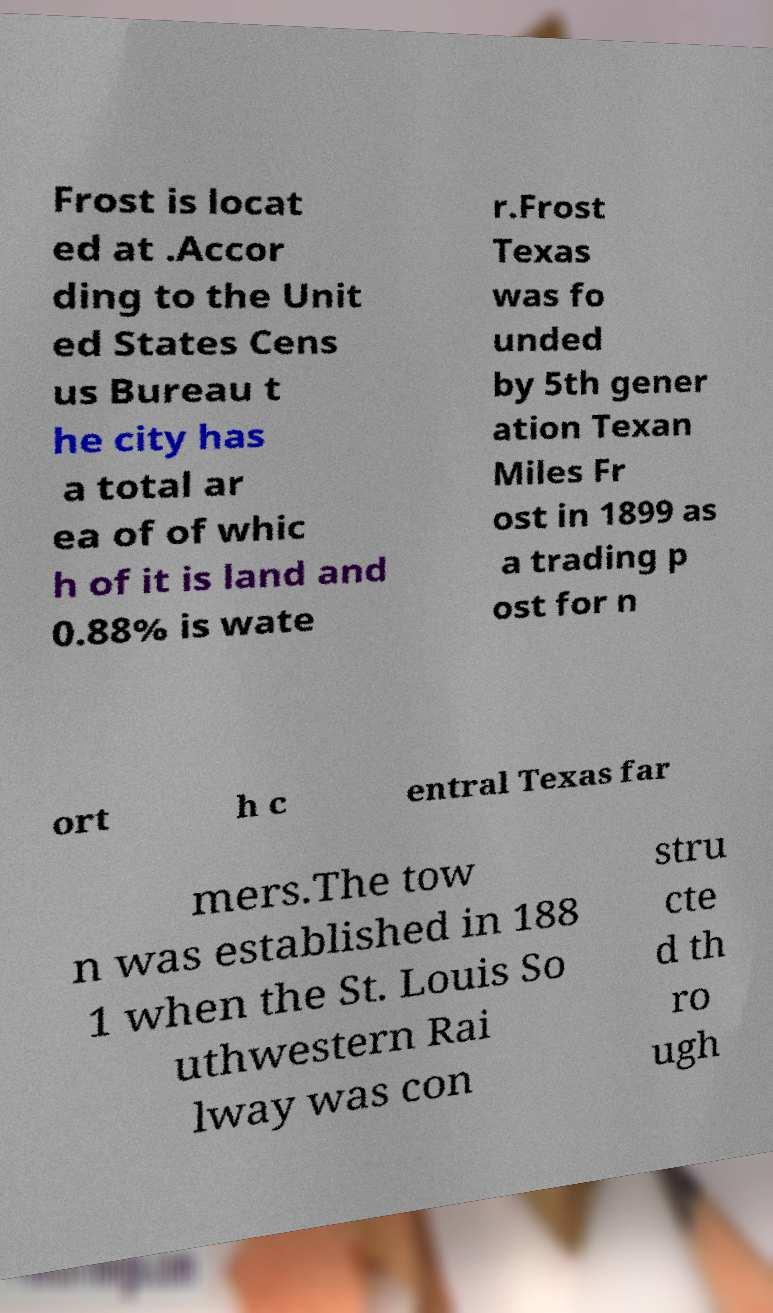Can you read and provide the text displayed in the image?This photo seems to have some interesting text. Can you extract and type it out for me? Frost is locat ed at .Accor ding to the Unit ed States Cens us Bureau t he city has a total ar ea of of whic h of it is land and 0.88% is wate r.Frost Texas was fo unded by 5th gener ation Texan Miles Fr ost in 1899 as a trading p ost for n ort h c entral Texas far mers.The tow n was established in 188 1 when the St. Louis So uthwestern Rai lway was con stru cte d th ro ugh 